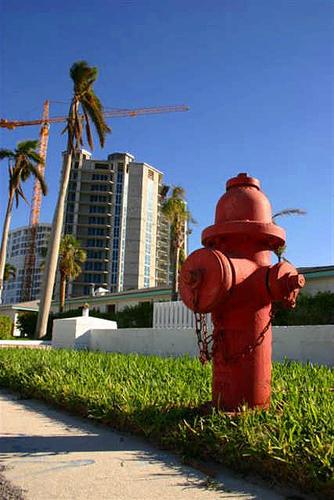What connects to it?
Write a very short answer. Hose. What kind of trees are there?
Quick response, please. Palm. What color is the hydrant?
Concise answer only. Red. 